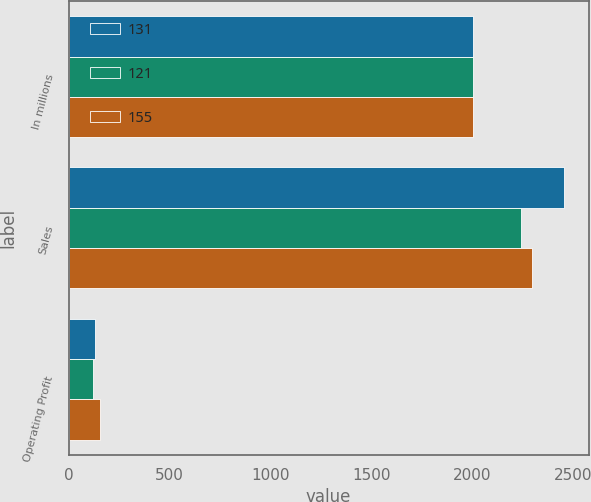Convert chart to OTSL. <chart><loc_0><loc_0><loc_500><loc_500><stacked_bar_chart><ecel><fcel>In millions<fcel>Sales<fcel>Operating Profit<nl><fcel>131<fcel>2006<fcel>2455<fcel>131<nl><fcel>121<fcel>2005<fcel>2245<fcel>121<nl><fcel>155<fcel>2004<fcel>2295<fcel>155<nl></chart> 